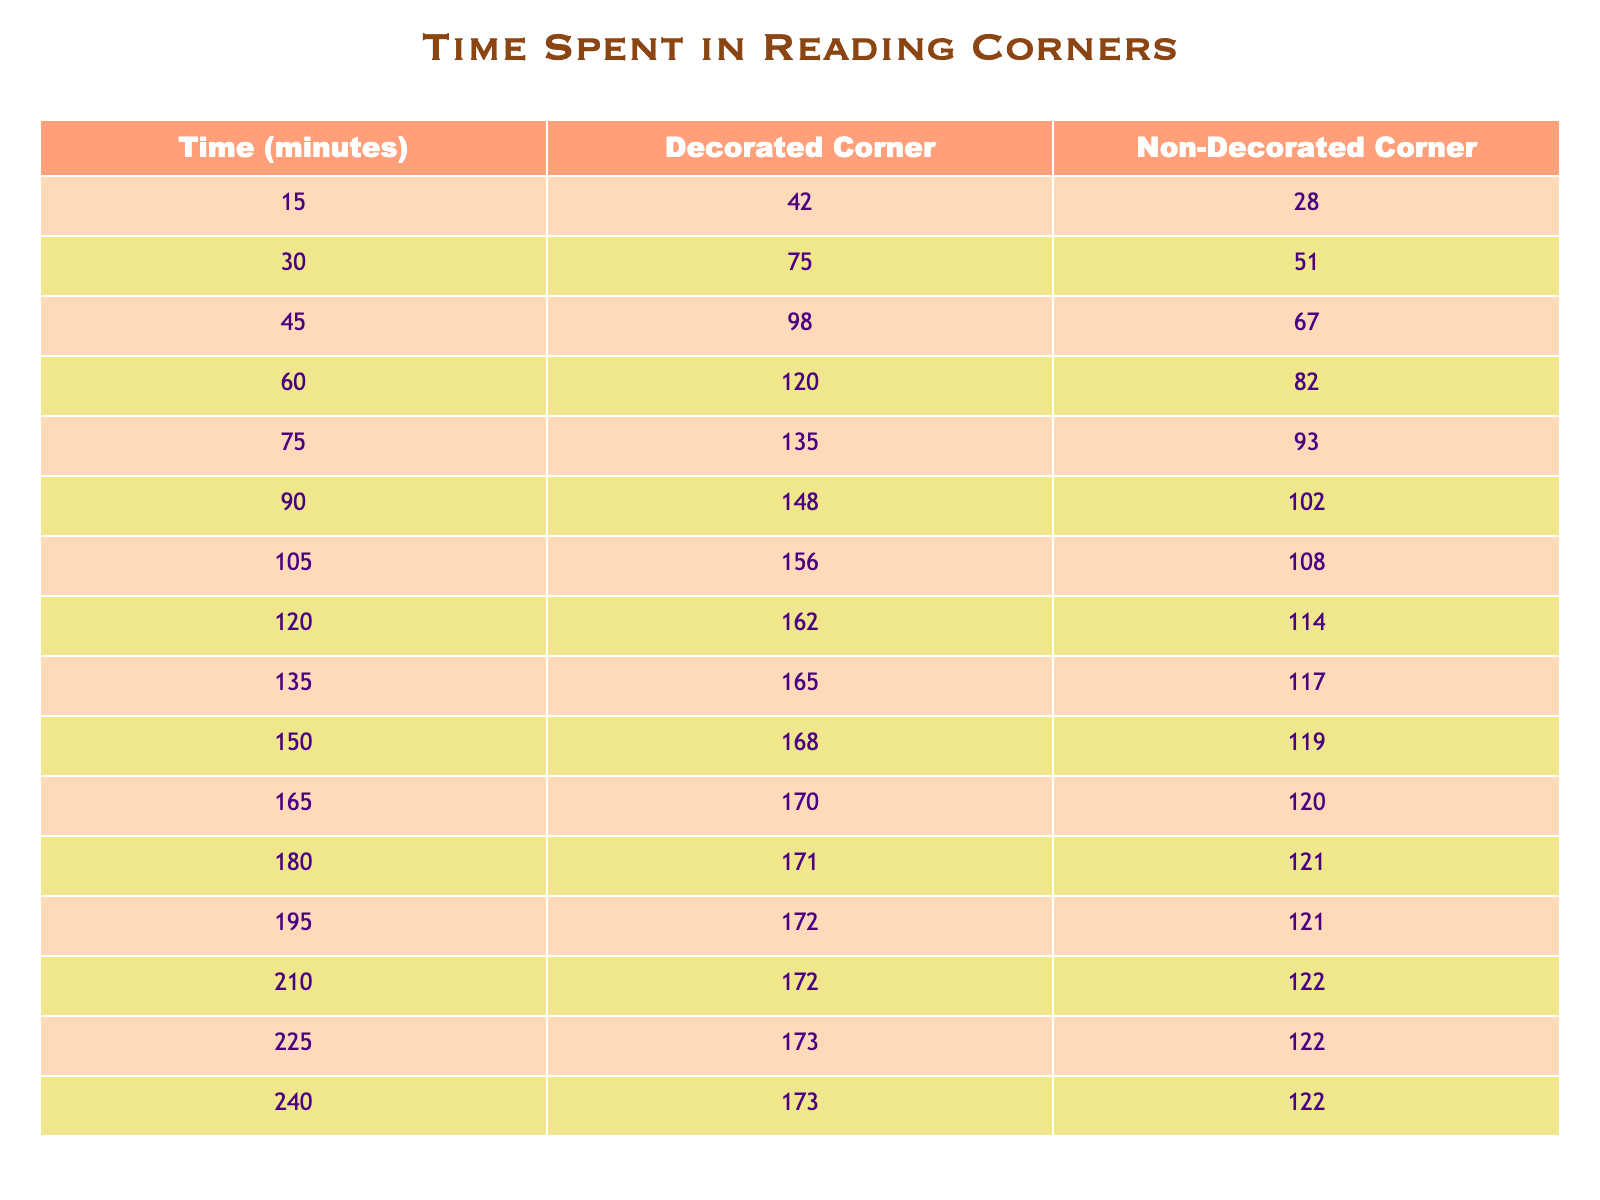What is the time spent in the decorated corner when visitors stayed for 90 minutes? According to the data in the table, for 90 minutes, the time spent in the decorated corner is listed as 148 minutes.
Answer: 148 What is the time spent in the non-decorated corner for a stay of 60 minutes? Looking at the table, the time spent in the non-decorated corner for 60 minutes is 82 minutes.
Answer: 82 How much more time do visitors spend in the decorated corner compared to the non-decorated corner at 150 minutes? For 150 minutes, time spent in the decorated corner is 168 minutes, while in the non-decorated corner it is 119 minutes. The difference is calculated as 168 - 119 = 49 minutes.
Answer: 49 What is the average time spent by visitors in the decorated corners across all time increments? To find the average for the decorated corners, we sum all the values: (42 + 75 + 98 + 120 + 135 + 148 + 156 + 162 + 165 + 168 + 170 + 171 + 172 + 172 + 173 + 173) = 2,403. There are 16 data points, so the average is 2,403 / 16 = 150.1875, which can be rounded to 150.19 minutes.
Answer: 150.19 At what duration do visitors start spending more time in decorated corners than in non-decorated corners? By analyzing the table, we see that for 15 minutes, visitors spent 42 minutes in decorated and 28 minutes in non-decorated corners. It continues to be the same until 15 minutes, where all subsequent times show decorated corners consistently higher than non-decorated. Therefore, visitors start spending more time in decorated corners right from the first data point.
Answer: 15 minutes Is the time spent in the decorated corner greater than 160 minutes for any time value of 210 minutes or more? In the 210-minute row, time spent in the decorated corner is 172 minutes, which is greater than 160 minutes.
Answer: Yes What is the total time spent by all visitors in the non-decorated corners from 0 to 240 minutes? To find the total time for non-decorated corners, we sum their values: (28 + 51 + 67 + 82 + 93 + 102 + 108 + 114 + 117 + 119 + 120 + 121 + 121 + 122 + 122 + 122) = 1,815 minutes.
Answer: 1815 What percentage more time do visitors spend in the decorated corners compared to the non-decorated corners for 120 minutes? At 120 minutes, visitors spend 162 minutes in decorated corners and 114 minutes in non-decorated corners. The difference is 162 - 114 = 48 minutes. To find the percentage, we calculate (48 / 114) * 100, which is approximately 42.11%.
Answer: 42.11% How consistent is the time spent in the non-decorated corner for the last three time increments (210, 225, 240 minutes)? Checking those data points, we see: 122, 122, and 122 minutes in the non-decorated corner. Since all values are the same, this demonstrates consistency.
Answer: Consistent 